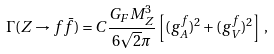Convert formula to latex. <formula><loc_0><loc_0><loc_500><loc_500>\Gamma ( Z \to f \bar { f } ) = C \frac { G _ { F } M _ { Z } ^ { 3 } } { 6 \sqrt { 2 } \pi } \left [ ( g _ { A } ^ { f } ) ^ { 2 } + ( g _ { V } ^ { f } ) ^ { 2 } \right ] \, ,</formula> 